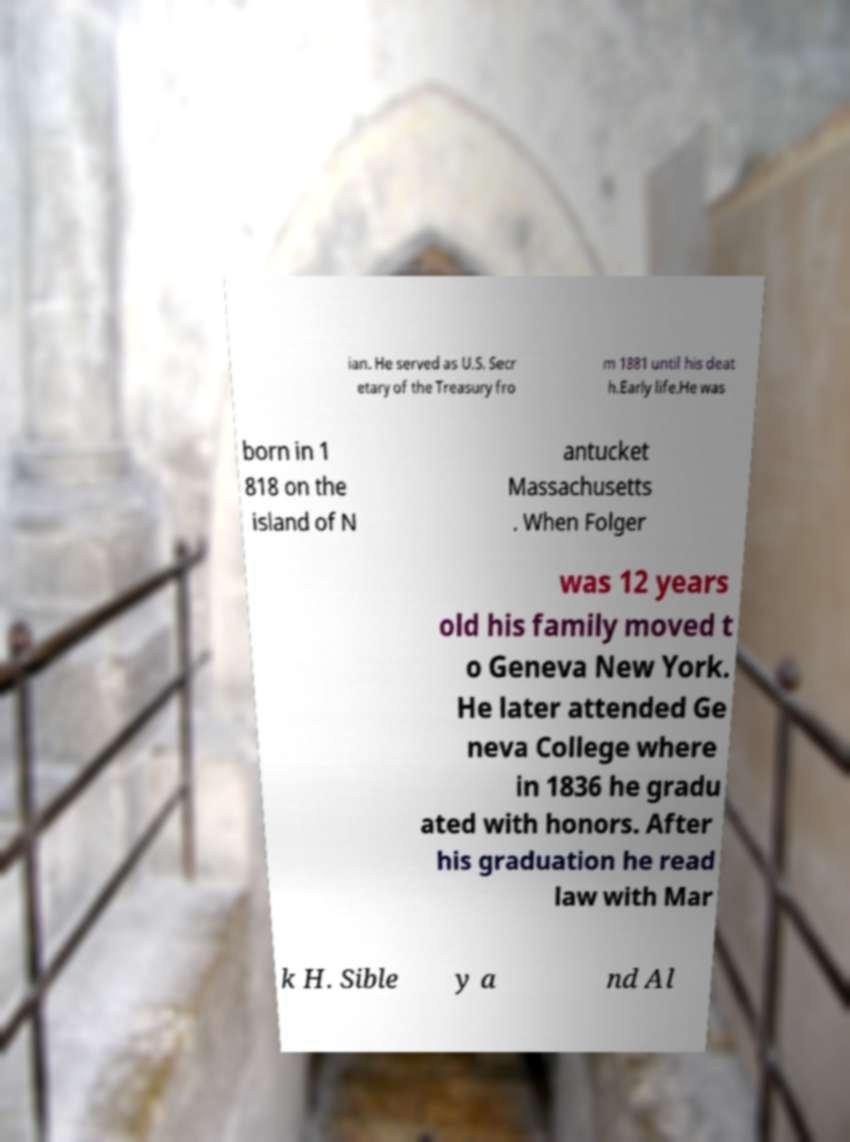Could you assist in decoding the text presented in this image and type it out clearly? ian. He served as U.S. Secr etary of the Treasury fro m 1881 until his deat h.Early life.He was born in 1 818 on the island of N antucket Massachusetts . When Folger was 12 years old his family moved t o Geneva New York. He later attended Ge neva College where in 1836 he gradu ated with honors. After his graduation he read law with Mar k H. Sible y a nd Al 